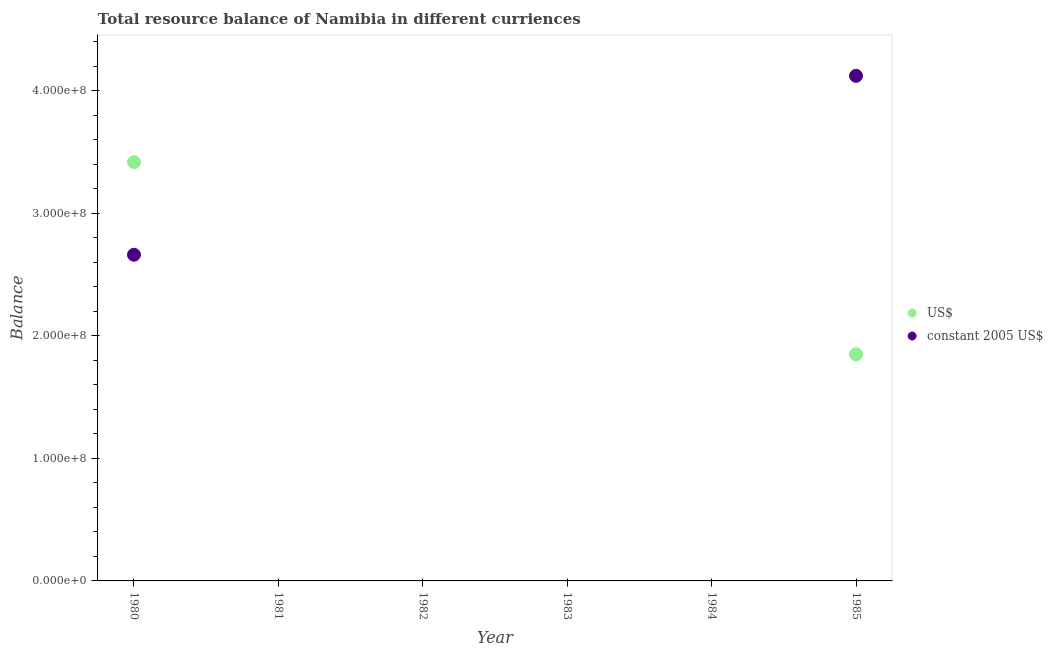Is the number of dotlines equal to the number of legend labels?
Keep it short and to the point. No. What is the resource balance in constant us$ in 1984?
Give a very brief answer. 0. Across all years, what is the maximum resource balance in us$?
Your response must be concise. 3.42e+08. In which year was the resource balance in us$ maximum?
Offer a terse response. 1980. What is the total resource balance in constant us$ in the graph?
Give a very brief answer. 6.78e+08. What is the difference between the resource balance in us$ in 1980 and that in 1985?
Your answer should be very brief. 1.57e+08. What is the difference between the resource balance in us$ in 1985 and the resource balance in constant us$ in 1984?
Keep it short and to the point. 1.85e+08. What is the average resource balance in constant us$ per year?
Give a very brief answer. 1.13e+08. In the year 1985, what is the difference between the resource balance in us$ and resource balance in constant us$?
Ensure brevity in your answer.  -2.27e+08. What is the difference between the highest and the lowest resource balance in us$?
Give a very brief answer. 3.42e+08. In how many years, is the resource balance in constant us$ greater than the average resource balance in constant us$ taken over all years?
Ensure brevity in your answer.  2. Does the resource balance in us$ monotonically increase over the years?
Offer a terse response. No. Is the resource balance in constant us$ strictly less than the resource balance in us$ over the years?
Provide a succinct answer. No. What is the difference between two consecutive major ticks on the Y-axis?
Provide a short and direct response. 1.00e+08. Where does the legend appear in the graph?
Your answer should be compact. Center right. How many legend labels are there?
Ensure brevity in your answer.  2. How are the legend labels stacked?
Make the answer very short. Vertical. What is the title of the graph?
Offer a very short reply. Total resource balance of Namibia in different curriences. What is the label or title of the X-axis?
Provide a short and direct response. Year. What is the label or title of the Y-axis?
Provide a short and direct response. Balance. What is the Balance of US$ in 1980?
Your response must be concise. 3.42e+08. What is the Balance in constant 2005 US$ in 1980?
Your answer should be very brief. 2.66e+08. What is the Balance in US$ in 1981?
Offer a very short reply. 0. What is the Balance of constant 2005 US$ in 1982?
Give a very brief answer. 0. What is the Balance in US$ in 1983?
Offer a terse response. 0. What is the Balance in constant 2005 US$ in 1983?
Keep it short and to the point. 0. What is the Balance of US$ in 1984?
Provide a succinct answer. 0. What is the Balance in US$ in 1985?
Ensure brevity in your answer.  1.85e+08. What is the Balance of constant 2005 US$ in 1985?
Give a very brief answer. 4.12e+08. Across all years, what is the maximum Balance of US$?
Your answer should be very brief. 3.42e+08. Across all years, what is the maximum Balance of constant 2005 US$?
Provide a short and direct response. 4.12e+08. Across all years, what is the minimum Balance of US$?
Your answer should be very brief. 0. Across all years, what is the minimum Balance in constant 2005 US$?
Give a very brief answer. 0. What is the total Balance of US$ in the graph?
Provide a short and direct response. 5.27e+08. What is the total Balance in constant 2005 US$ in the graph?
Give a very brief answer. 6.78e+08. What is the difference between the Balance in US$ in 1980 and that in 1985?
Your answer should be very brief. 1.57e+08. What is the difference between the Balance of constant 2005 US$ in 1980 and that in 1985?
Make the answer very short. -1.46e+08. What is the difference between the Balance of US$ in 1980 and the Balance of constant 2005 US$ in 1985?
Provide a short and direct response. -7.04e+07. What is the average Balance of US$ per year?
Your answer should be very brief. 8.78e+07. What is the average Balance of constant 2005 US$ per year?
Make the answer very short. 1.13e+08. In the year 1980, what is the difference between the Balance of US$ and Balance of constant 2005 US$?
Provide a short and direct response. 7.56e+07. In the year 1985, what is the difference between the Balance in US$ and Balance in constant 2005 US$?
Your response must be concise. -2.27e+08. What is the ratio of the Balance in US$ in 1980 to that in 1985?
Your answer should be very brief. 1.85. What is the ratio of the Balance of constant 2005 US$ in 1980 to that in 1985?
Your response must be concise. 0.65. What is the difference between the highest and the lowest Balance in US$?
Keep it short and to the point. 3.42e+08. What is the difference between the highest and the lowest Balance in constant 2005 US$?
Provide a succinct answer. 4.12e+08. 